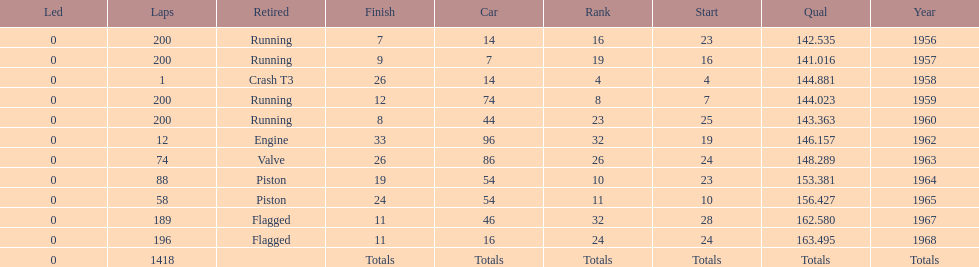Could you parse the entire table as a dict? {'header': ['Led', 'Laps', 'Retired', 'Finish', 'Car', 'Rank', 'Start', 'Qual', 'Year'], 'rows': [['0', '200', 'Running', '7', '14', '16', '23', '142.535', '1956'], ['0', '200', 'Running', '9', '7', '19', '16', '141.016', '1957'], ['0', '1', 'Crash T3', '26', '14', '4', '4', '144.881', '1958'], ['0', '200', 'Running', '12', '74', '8', '7', '144.023', '1959'], ['0', '200', 'Running', '8', '44', '23', '25', '143.363', '1960'], ['0', '12', 'Engine', '33', '96', '32', '19', '146.157', '1962'], ['0', '74', 'Valve', '26', '86', '26', '24', '148.289', '1963'], ['0', '88', 'Piston', '19', '54', '10', '23', '153.381', '1964'], ['0', '58', 'Piston', '24', '54', '11', '10', '156.427', '1965'], ['0', '189', 'Flagged', '11', '46', '32', '28', '162.580', '1967'], ['0', '196', 'Flagged', '11', '16', '24', '24', '163.495', '1968'], ['0', '1418', '', 'Totals', 'Totals', 'Totals', 'Totals', 'Totals', 'Totals']]} What was the last year that it finished the race? 1968. 